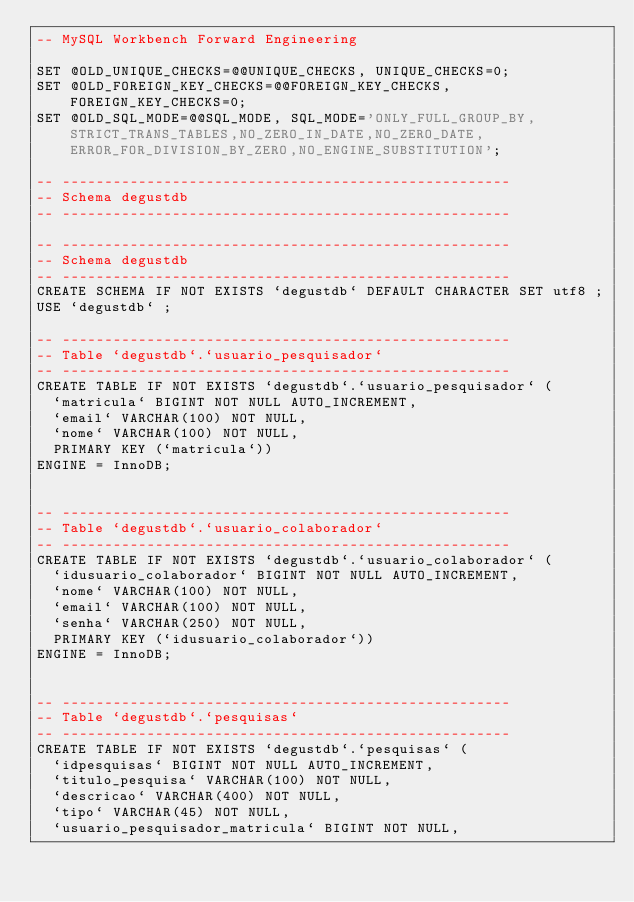<code> <loc_0><loc_0><loc_500><loc_500><_SQL_>-- MySQL Workbench Forward Engineering

SET @OLD_UNIQUE_CHECKS=@@UNIQUE_CHECKS, UNIQUE_CHECKS=0;
SET @OLD_FOREIGN_KEY_CHECKS=@@FOREIGN_KEY_CHECKS, FOREIGN_KEY_CHECKS=0;
SET @OLD_SQL_MODE=@@SQL_MODE, SQL_MODE='ONLY_FULL_GROUP_BY,STRICT_TRANS_TABLES,NO_ZERO_IN_DATE,NO_ZERO_DATE,ERROR_FOR_DIVISION_BY_ZERO,NO_ENGINE_SUBSTITUTION';

-- -----------------------------------------------------
-- Schema degustdb
-- -----------------------------------------------------

-- -----------------------------------------------------
-- Schema degustdb
-- -----------------------------------------------------
CREATE SCHEMA IF NOT EXISTS `degustdb` DEFAULT CHARACTER SET utf8 ;
USE `degustdb` ;

-- -----------------------------------------------------
-- Table `degustdb`.`usuario_pesquisador`
-- -----------------------------------------------------
CREATE TABLE IF NOT EXISTS `degustdb`.`usuario_pesquisador` (
  `matricula` BIGINT NOT NULL AUTO_INCREMENT,
  `email` VARCHAR(100) NOT NULL,
  `nome` VARCHAR(100) NOT NULL,
  PRIMARY KEY (`matricula`))
ENGINE = InnoDB;


-- -----------------------------------------------------
-- Table `degustdb`.`usuario_colaborador`
-- -----------------------------------------------------
CREATE TABLE IF NOT EXISTS `degustdb`.`usuario_colaborador` (
  `idusuario_colaborador` BIGINT NOT NULL AUTO_INCREMENT,
  `nome` VARCHAR(100) NOT NULL,
  `email` VARCHAR(100) NOT NULL,
  `senha` VARCHAR(250) NOT NULL,
  PRIMARY KEY (`idusuario_colaborador`))
ENGINE = InnoDB;


-- -----------------------------------------------------
-- Table `degustdb`.`pesquisas`
-- -----------------------------------------------------
CREATE TABLE IF NOT EXISTS `degustdb`.`pesquisas` (
  `idpesquisas` BIGINT NOT NULL AUTO_INCREMENT,
  `titulo_pesquisa` VARCHAR(100) NOT NULL,
  `descricao` VARCHAR(400) NOT NULL,
  `tipo` VARCHAR(45) NOT NULL,
  `usuario_pesquisador_matricula` BIGINT NOT NULL,</code> 